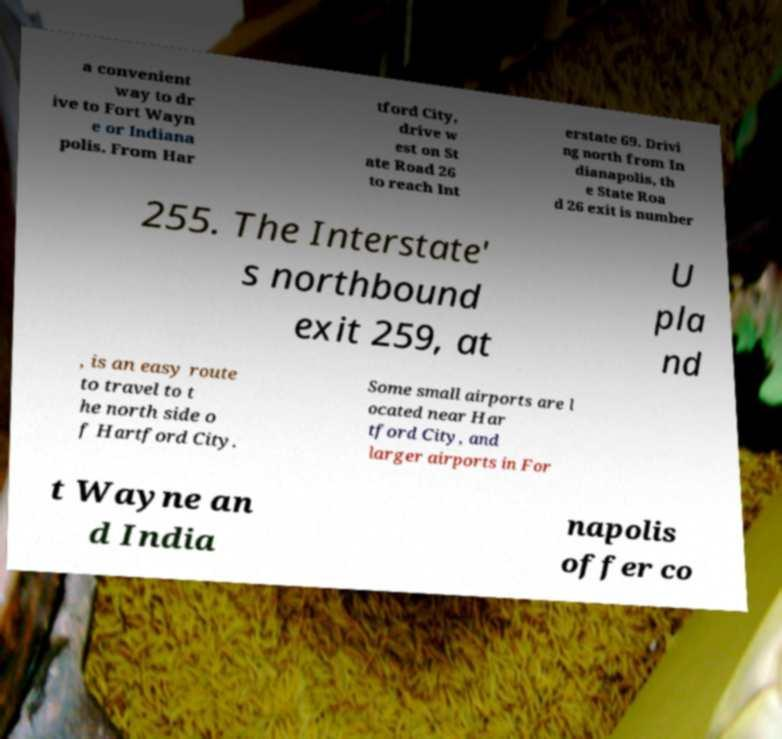What messages or text are displayed in this image? I need them in a readable, typed format. a convenient way to dr ive to Fort Wayn e or Indiana polis. From Har tford City, drive w est on St ate Road 26 to reach Int erstate 69. Drivi ng north from In dianapolis, th e State Roa d 26 exit is number 255. The Interstate' s northbound exit 259, at U pla nd , is an easy route to travel to t he north side o f Hartford City. Some small airports are l ocated near Har tford City, and larger airports in For t Wayne an d India napolis offer co 